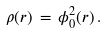<formula> <loc_0><loc_0><loc_500><loc_500>\rho ( { r } ) \, = \, \phi _ { 0 } ^ { 2 } ( { r } ) \, .</formula> 